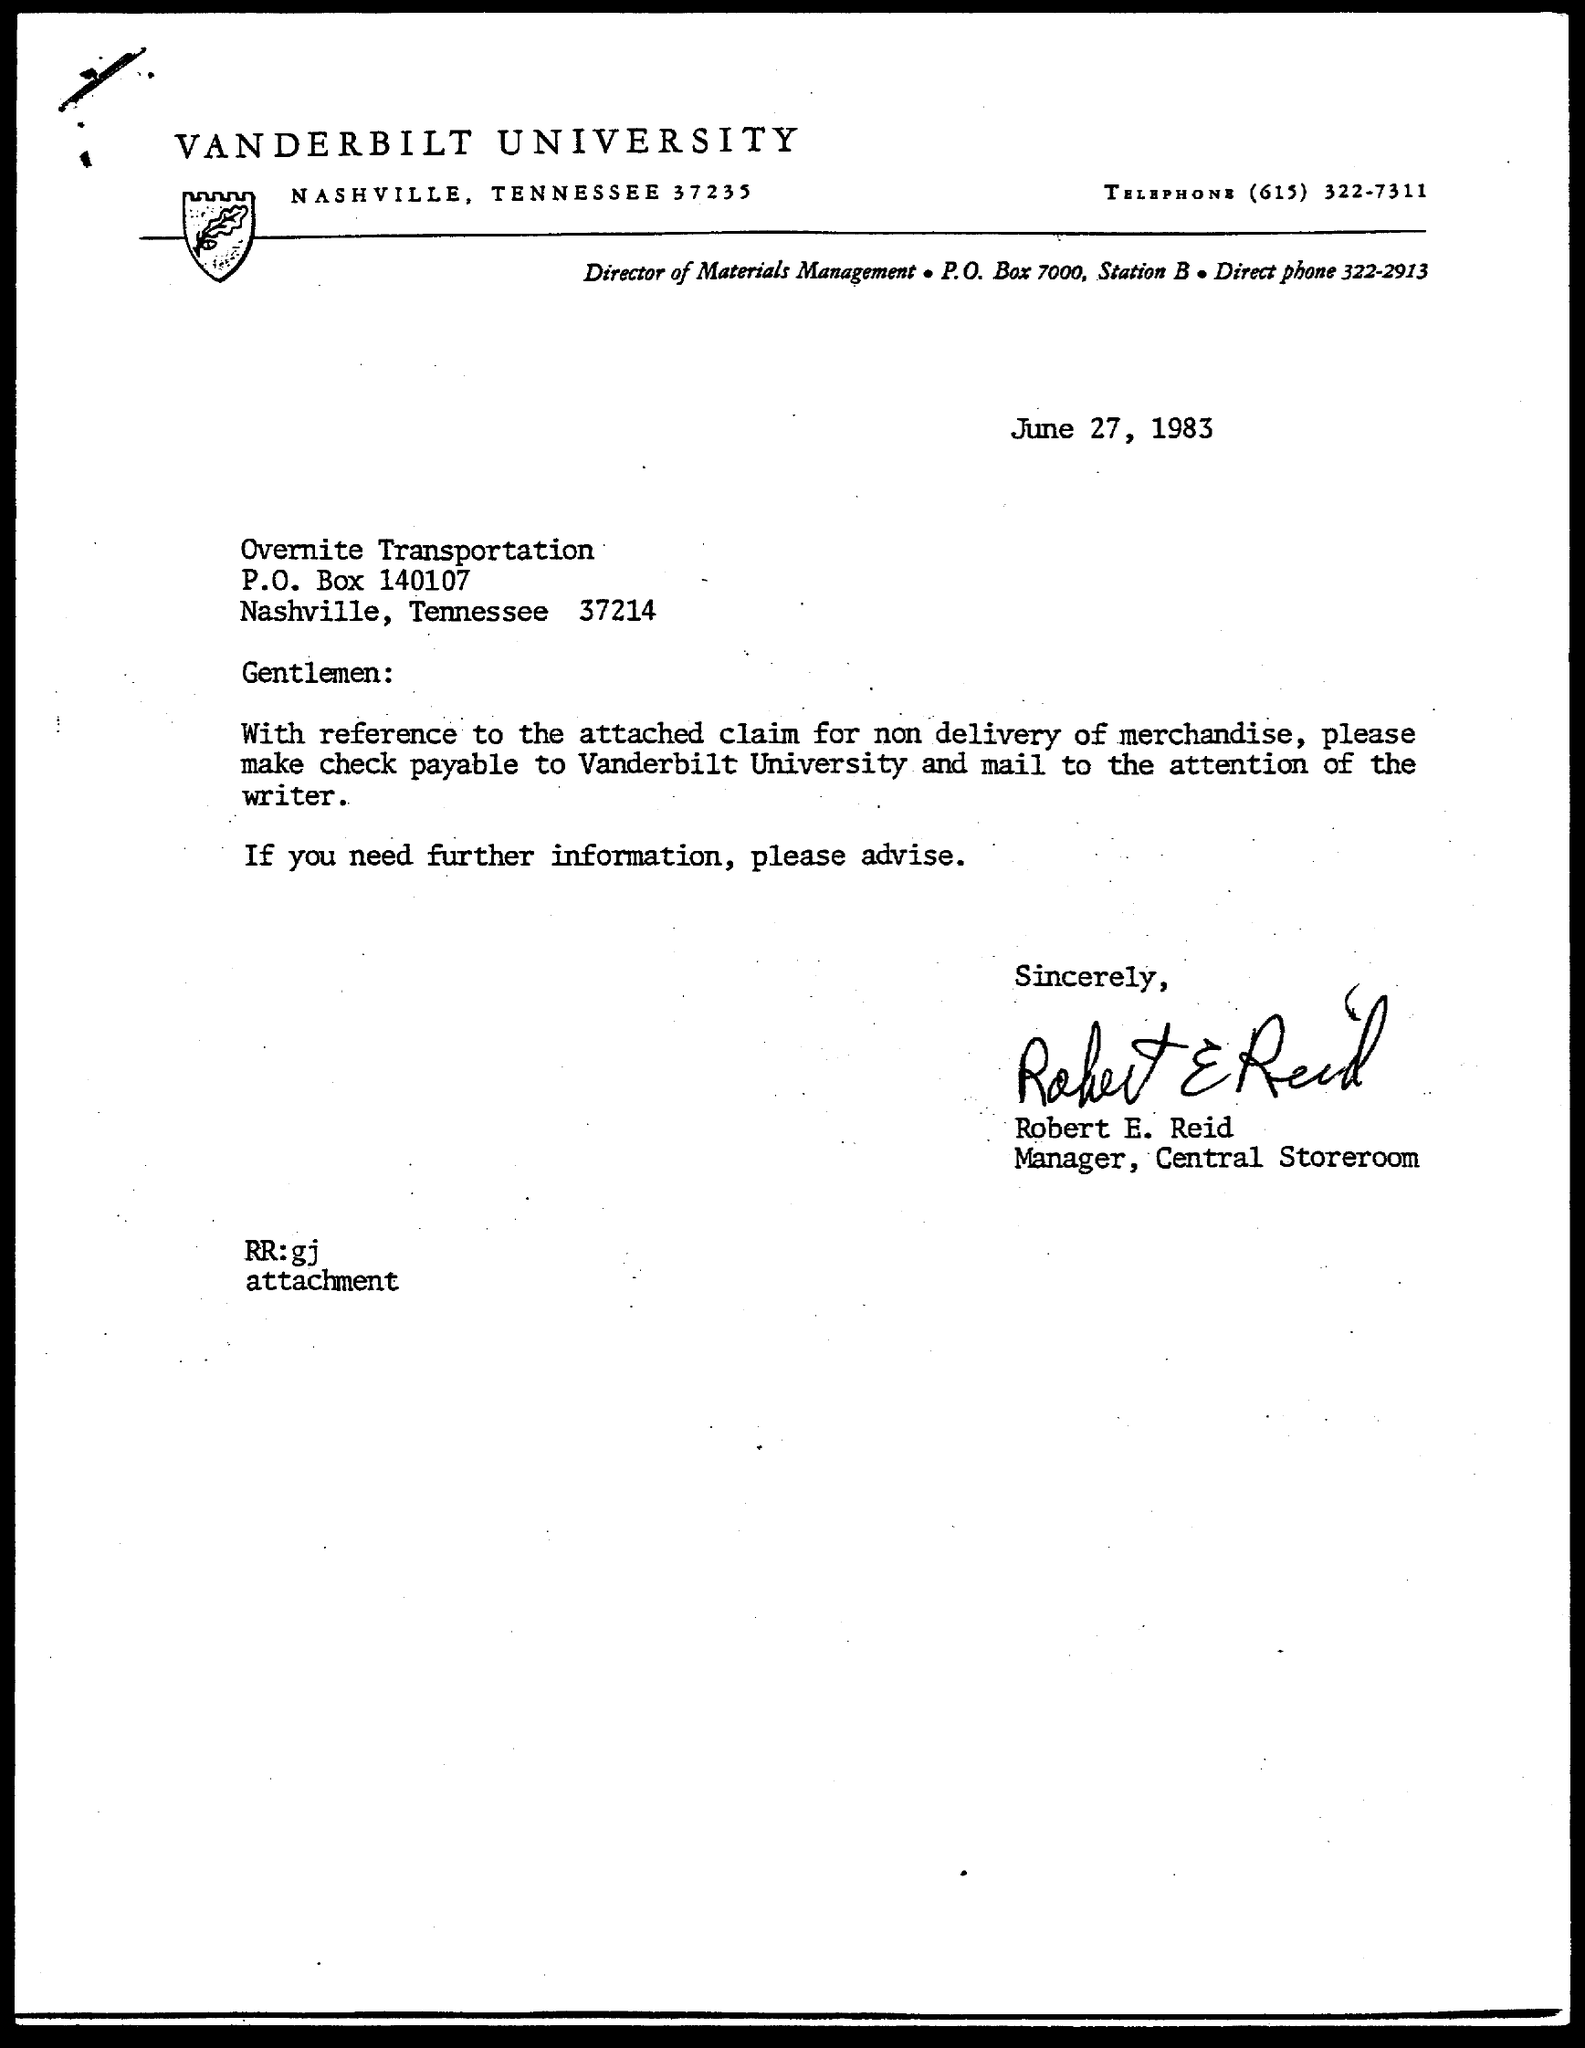Give some essential details in this illustration. Robert E. Reid is the manager. 